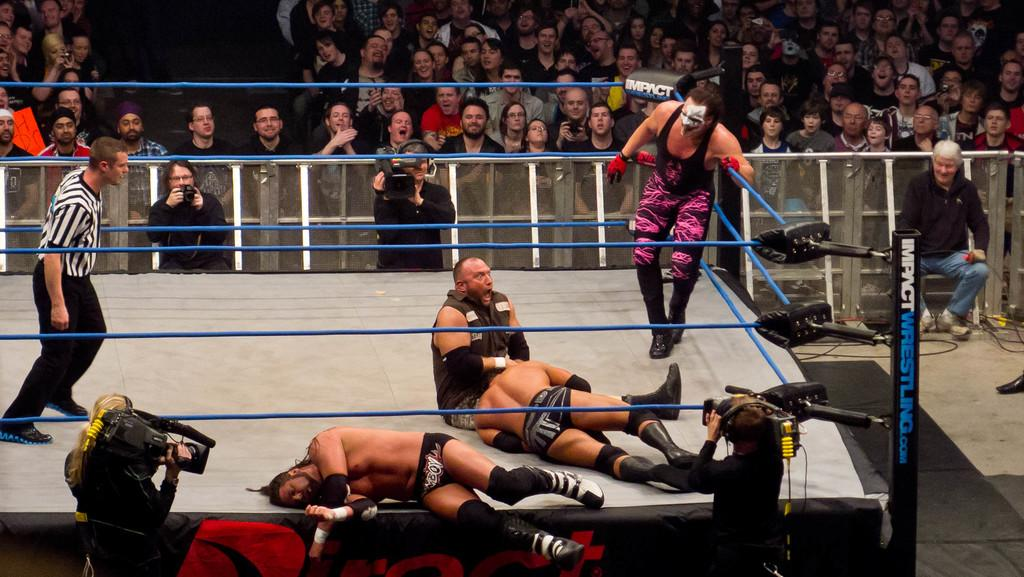<image>
Give a short and clear explanation of the subsequent image. Wrestlers on a ring with a post labeled impactwrestling.com. 